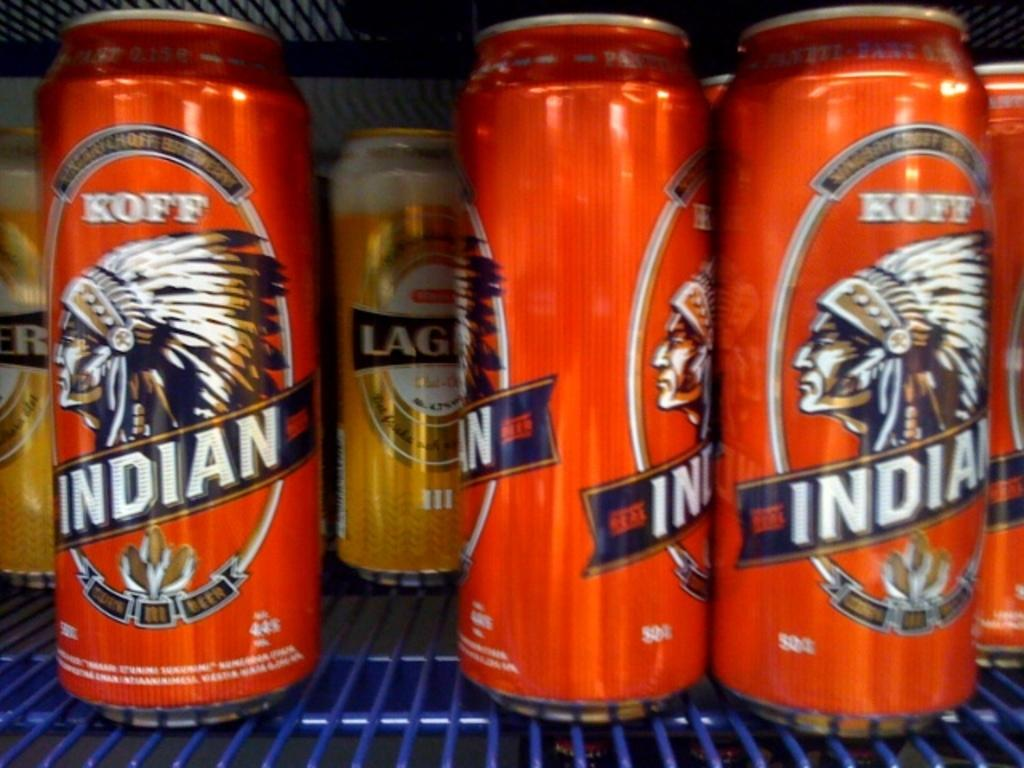<image>
Offer a succinct explanation of the picture presented. Several bright orange cans of Koff Indian beer. 